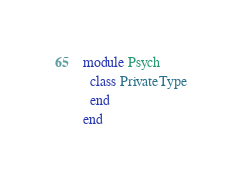Convert code to text. <code><loc_0><loc_0><loc_500><loc_500><_Ruby_>module Psych
  class PrivateType
  end
end
</code> 